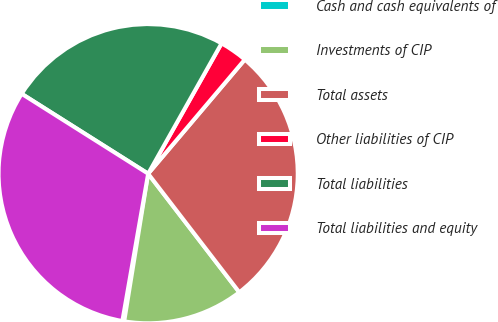Convert chart to OTSL. <chart><loc_0><loc_0><loc_500><loc_500><pie_chart><fcel>Cash and cash equivalents of<fcel>Investments of CIP<fcel>Total assets<fcel>Other liabilities of CIP<fcel>Total liabilities<fcel>Total liabilities and equity<nl><fcel>0.2%<fcel>12.99%<fcel>28.39%<fcel>3.02%<fcel>24.2%<fcel>31.21%<nl></chart> 